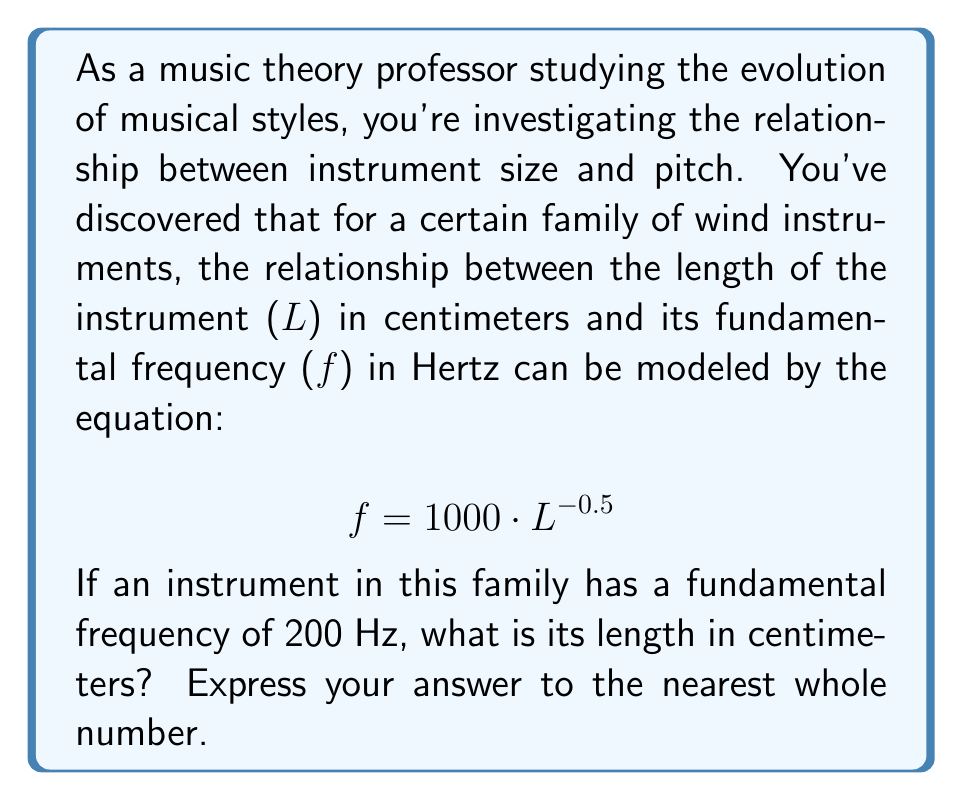What is the answer to this math problem? To solve this problem, we need to use the given logarithmic relationship and apply algebraic manipulation to isolate the length (L).

1) Start with the given equation:
   $$ f = 1000 \cdot L^{-0.5} $$

2) Substitute the known frequency:
   $$ 200 = 1000 \cdot L^{-0.5} $$

3) Divide both sides by 1000:
   $$ \frac{200}{1000} = L^{-0.5} $$
   $$ 0.2 = L^{-0.5} $$

4) To isolate L, we need to apply the inverse operation of the exponent -0.5. This means squaring both sides and then taking the reciprocal:
   $$ (0.2)^2 = (L^{-0.5})^2 = L^{-1} $$
   $$ 0.04 = L^{-1} $$

5) Take the reciprocal of both sides:
   $$ \frac{1}{0.04} = \frac{1}{L^{-1}} = L $$

6) Calculate the final result:
   $$ L = 25 $$

Therefore, the length of the instrument is 25 cm.
Answer: 25 cm 